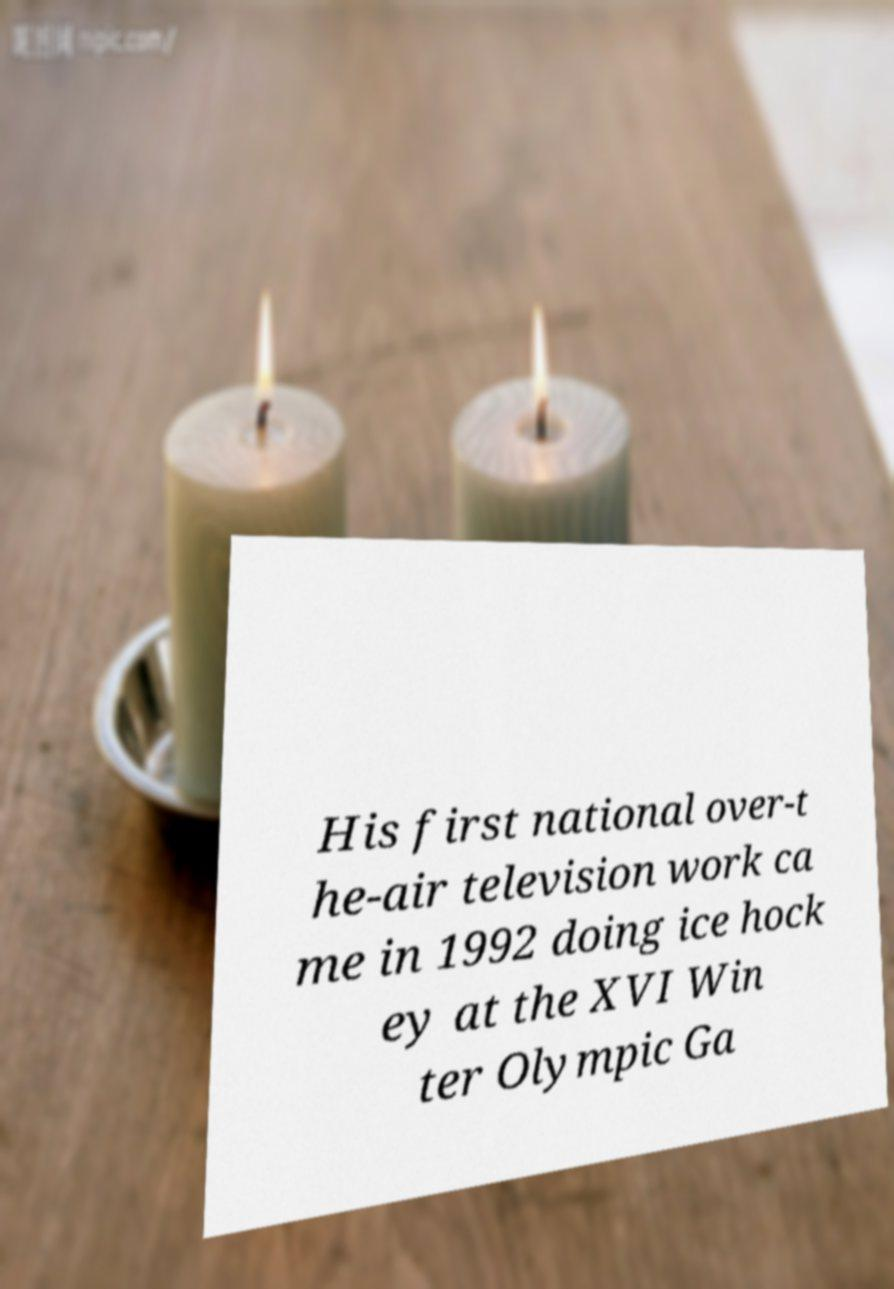Please identify and transcribe the text found in this image. His first national over-t he-air television work ca me in 1992 doing ice hock ey at the XVI Win ter Olympic Ga 